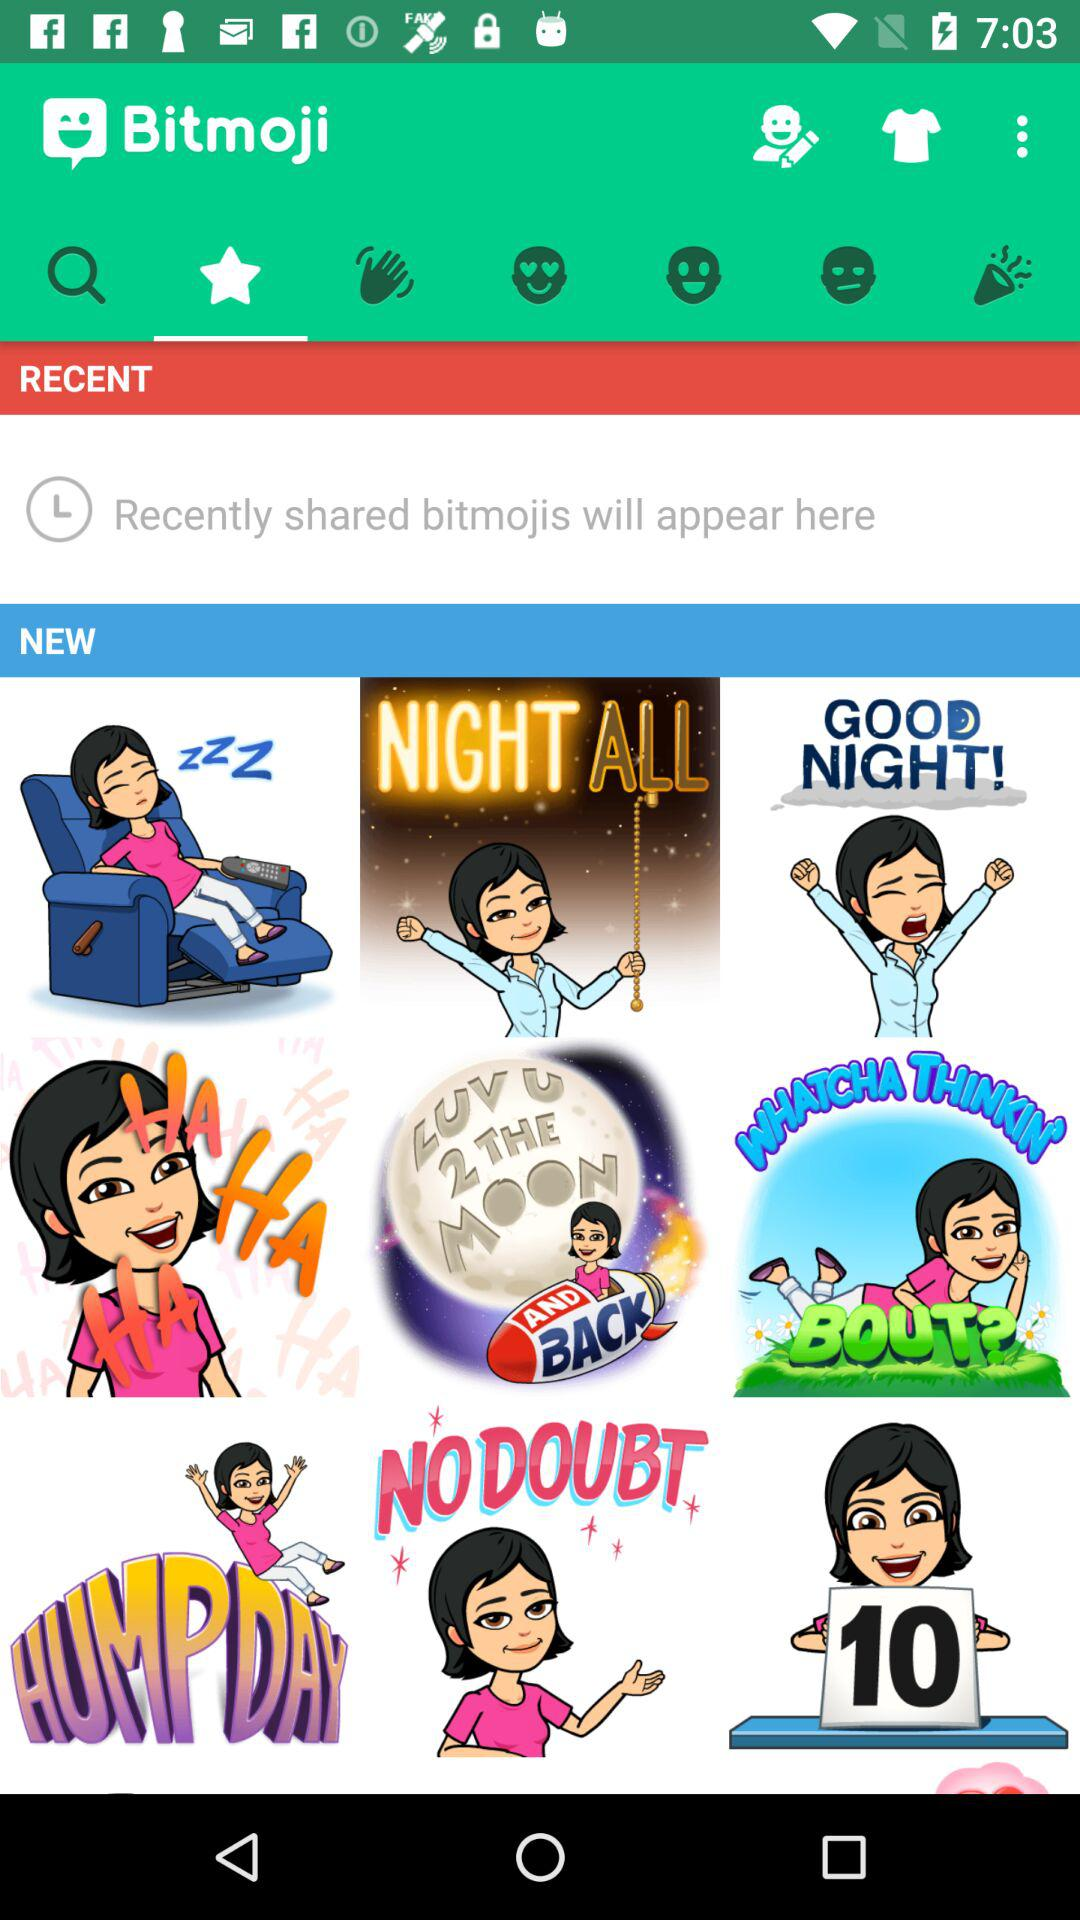What is the user's name?
When the provided information is insufficient, respond with <no answer>. <no answer> 